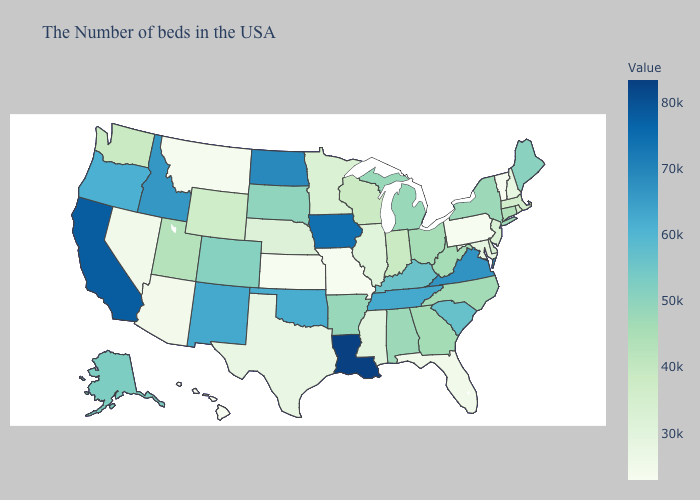Does Oklahoma have the highest value in the South?
Answer briefly. No. Which states hav the highest value in the West?
Keep it brief. California. Is the legend a continuous bar?
Be succinct. Yes. Among the states that border Rhode Island , does Connecticut have the highest value?
Keep it brief. Yes. Which states have the lowest value in the USA?
Keep it brief. Vermont, Pennsylvania, Missouri, Kansas, Hawaii. Among the states that border Oklahoma , does New Mexico have the highest value?
Quick response, please. Yes. Among the states that border Illinois , does Missouri have the highest value?
Short answer required. No. 